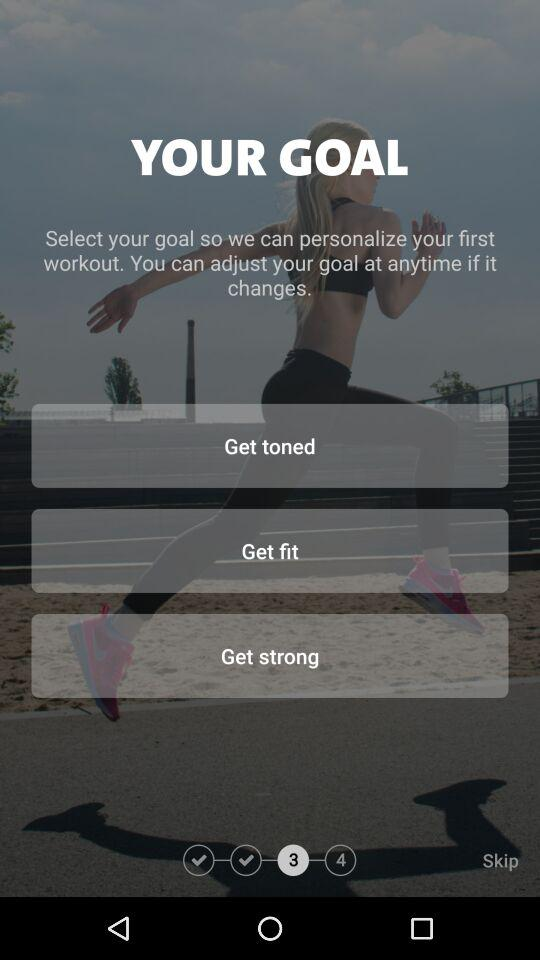How many steps are there in the onboarding process?
Answer the question using a single word or phrase. 4 